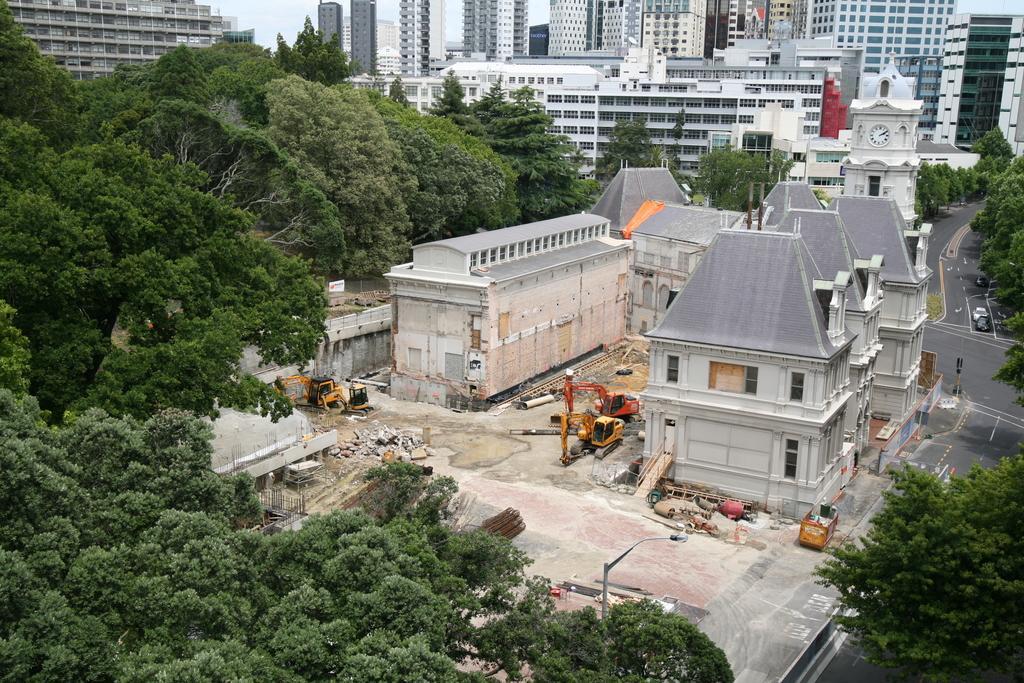Can you describe this image briefly? We can see trees and vehicles. In the background we can see cars on the road,buildings and sky. 